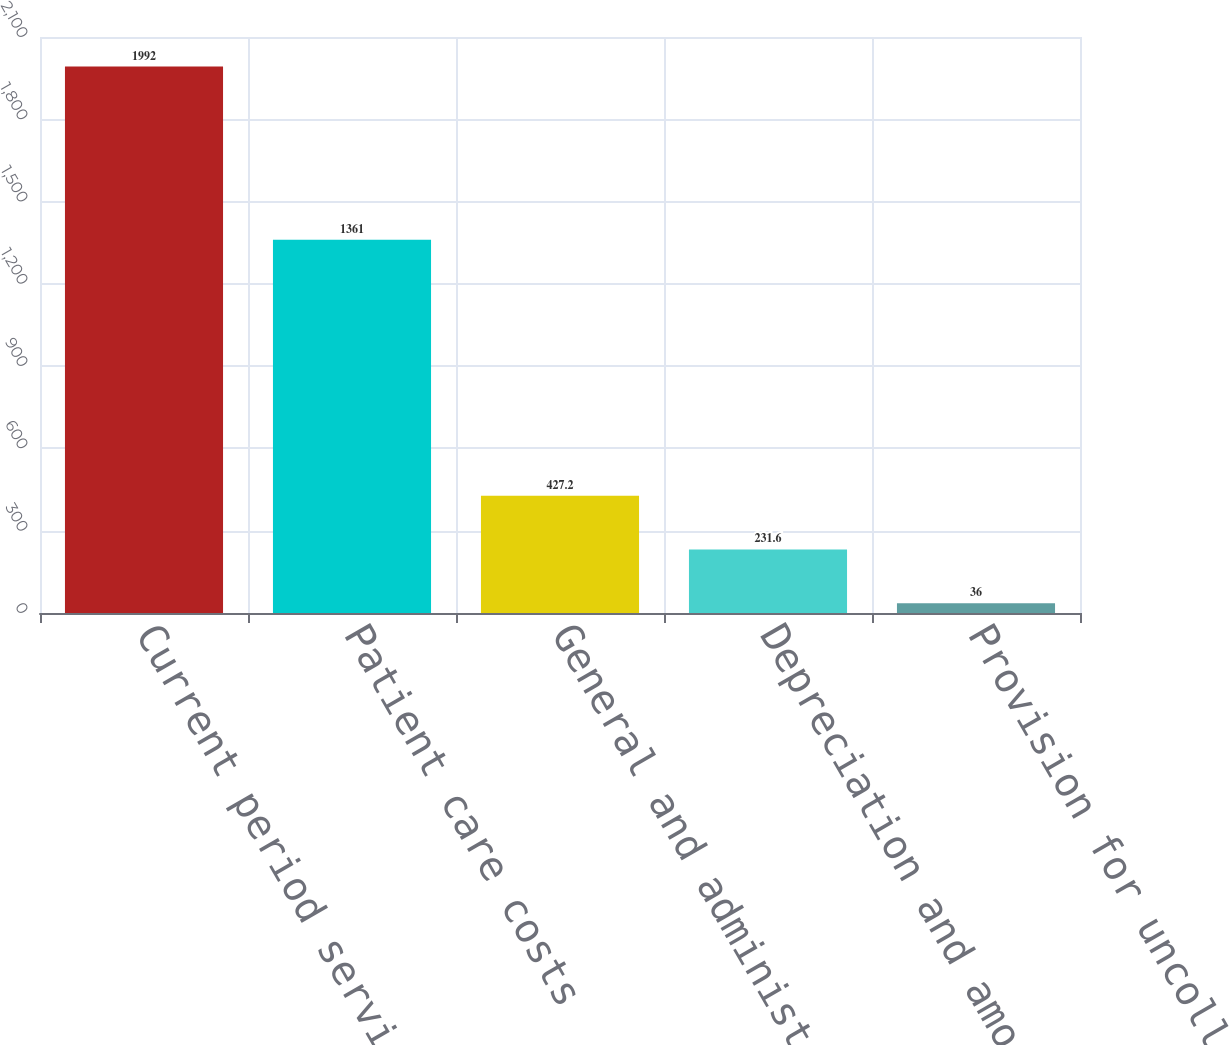<chart> <loc_0><loc_0><loc_500><loc_500><bar_chart><fcel>Current period services<fcel>Patient care costs<fcel>General and administrative<fcel>Depreciation and amortization<fcel>Provision for uncollectible<nl><fcel>1992<fcel>1361<fcel>427.2<fcel>231.6<fcel>36<nl></chart> 